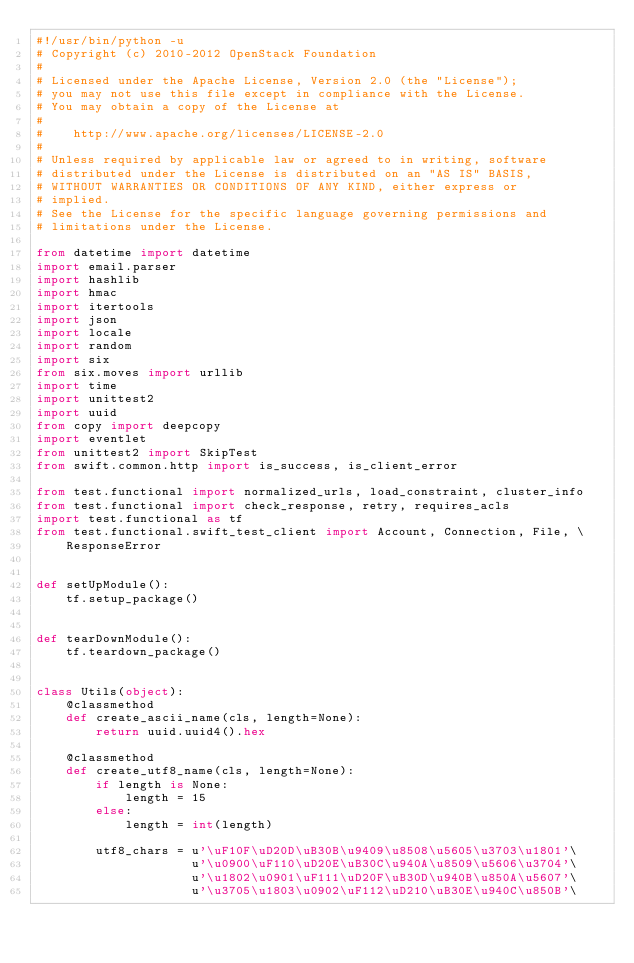Convert code to text. <code><loc_0><loc_0><loc_500><loc_500><_Python_>#!/usr/bin/python -u
# Copyright (c) 2010-2012 OpenStack Foundation
#
# Licensed under the Apache License, Version 2.0 (the "License");
# you may not use this file except in compliance with the License.
# You may obtain a copy of the License at
#
#    http://www.apache.org/licenses/LICENSE-2.0
#
# Unless required by applicable law or agreed to in writing, software
# distributed under the License is distributed on an "AS IS" BASIS,
# WITHOUT WARRANTIES OR CONDITIONS OF ANY KIND, either express or
# implied.
# See the License for the specific language governing permissions and
# limitations under the License.

from datetime import datetime
import email.parser
import hashlib
import hmac
import itertools
import json
import locale
import random
import six
from six.moves import urllib
import time
import unittest2
import uuid
from copy import deepcopy
import eventlet
from unittest2 import SkipTest
from swift.common.http import is_success, is_client_error

from test.functional import normalized_urls, load_constraint, cluster_info
from test.functional import check_response, retry, requires_acls
import test.functional as tf
from test.functional.swift_test_client import Account, Connection, File, \
    ResponseError


def setUpModule():
    tf.setup_package()


def tearDownModule():
    tf.teardown_package()


class Utils(object):
    @classmethod
    def create_ascii_name(cls, length=None):
        return uuid.uuid4().hex

    @classmethod
    def create_utf8_name(cls, length=None):
        if length is None:
            length = 15
        else:
            length = int(length)

        utf8_chars = u'\uF10F\uD20D\uB30B\u9409\u8508\u5605\u3703\u1801'\
                     u'\u0900\uF110\uD20E\uB30C\u940A\u8509\u5606\u3704'\
                     u'\u1802\u0901\uF111\uD20F\uB30D\u940B\u850A\u5607'\
                     u'\u3705\u1803\u0902\uF112\uD210\uB30E\u940C\u850B'\</code> 